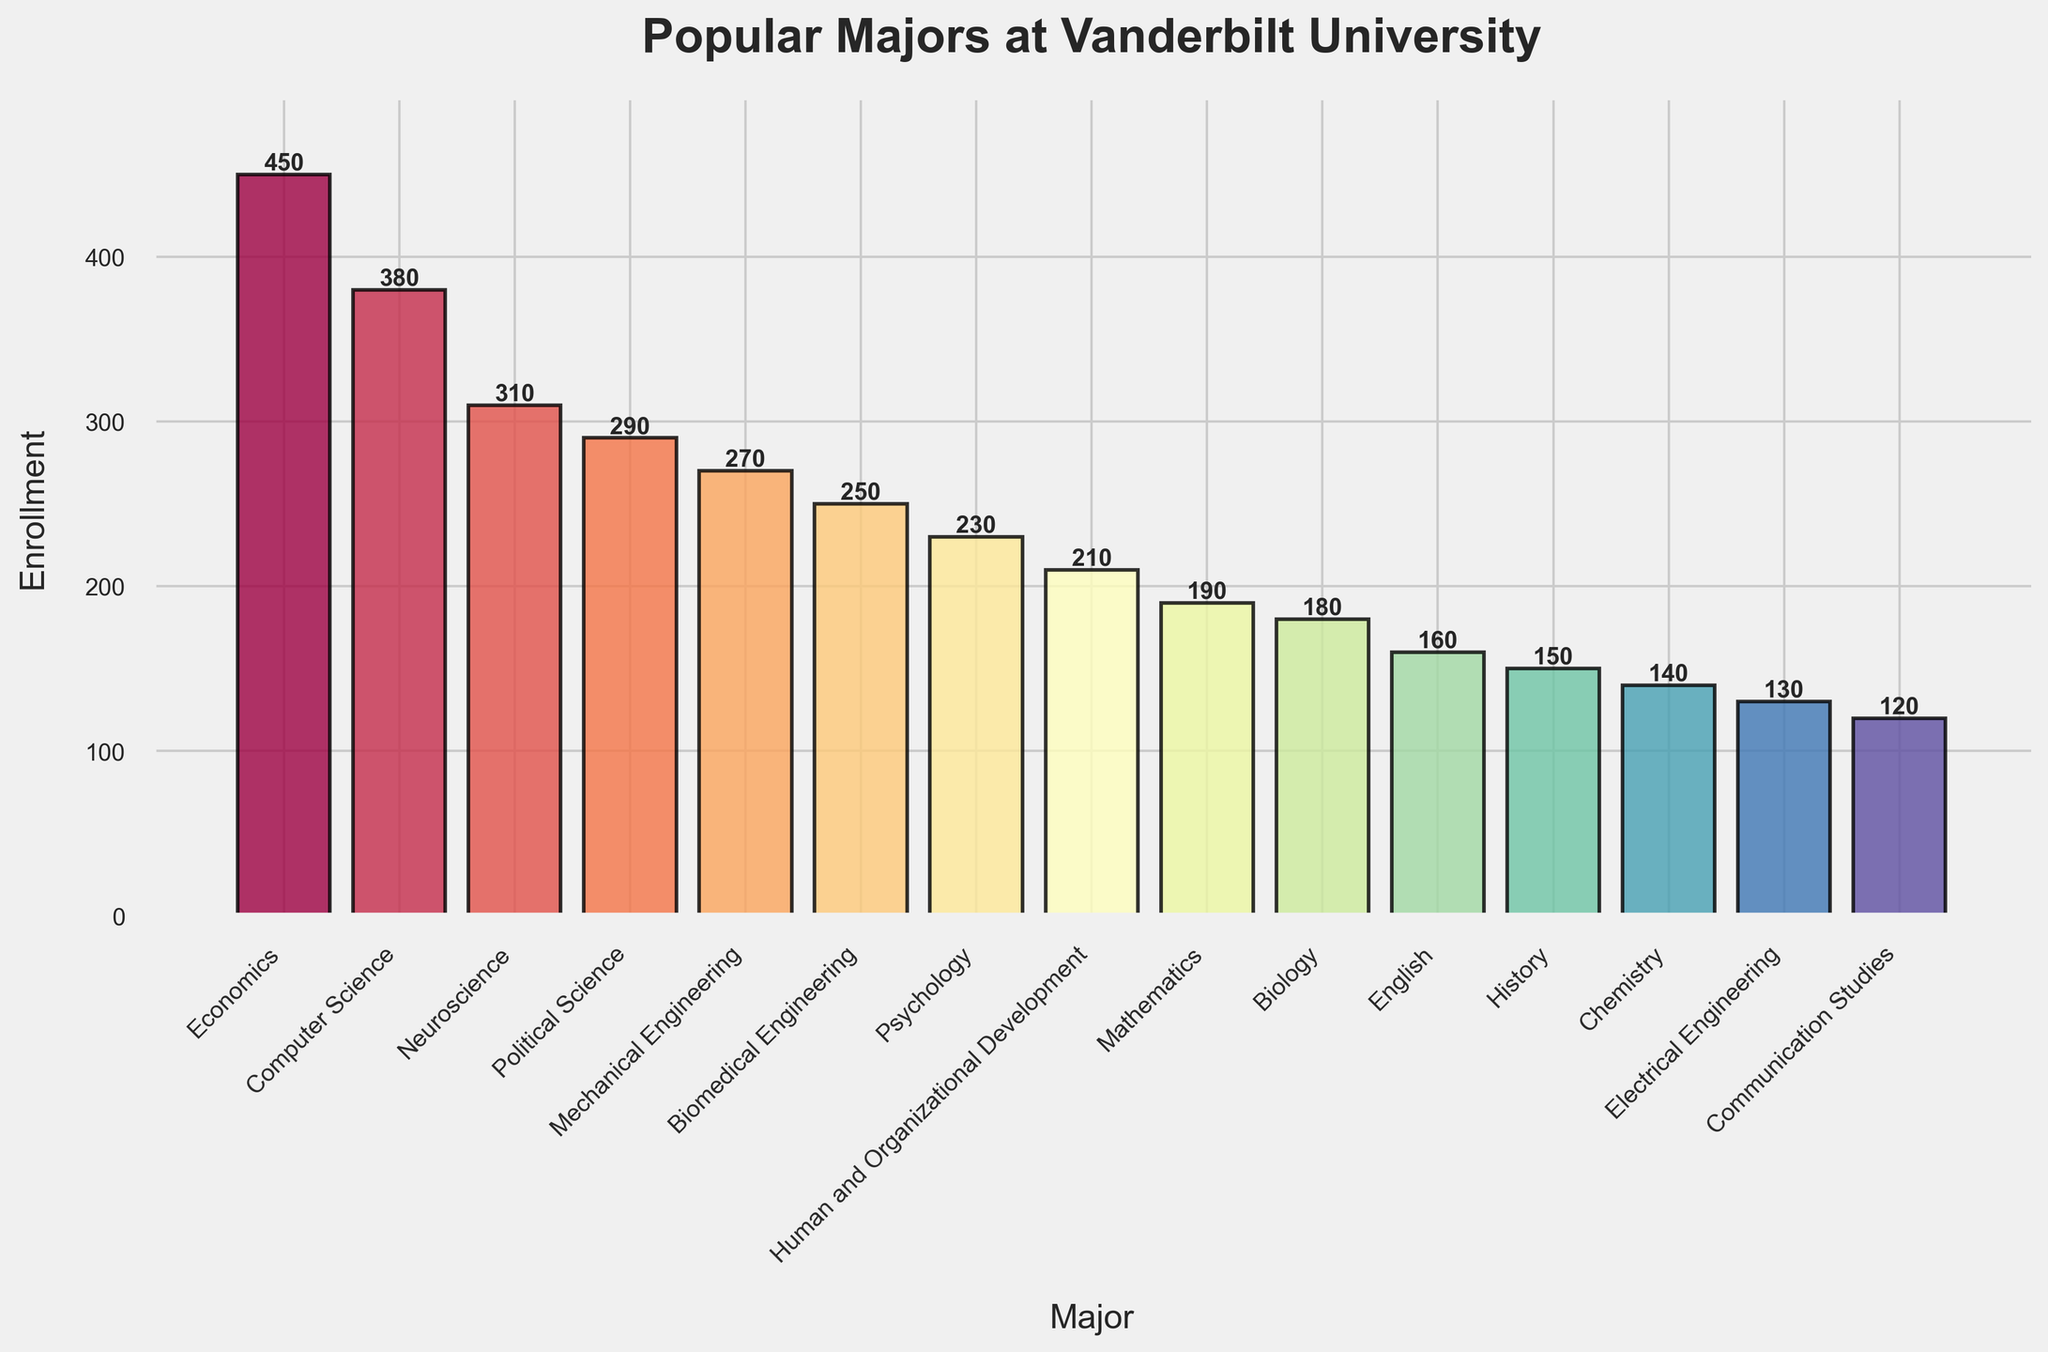Which major has the highest enrollment? By looking at the height of the bars, the tallest bar represents Economics with an enrollment of 450 students.
Answer: Economics Which major has the lowest enrollment? By observing the height of the bars, the shortest bar represents Communication Studies with an enrollment of 120 students.
Answer: Communication Studies What is the difference in enrollment between Economics and Computer Science? The enrollment for Economics is 450, and for Computer Science, it is 380. The difference can be calculated as 450 - 380 = 70.
Answer: 70 How many students are enrolled in the top three most popular majors combined? The top three majors by height of the bars are Economics (450), Computer Science (380), and Neuroscience (310). The combined enrollment is 450 + 380 + 310 = 1140.
Answer: 1140 Is the enrollment in Political Science greater or less than in Mechanical Engineering? By comparing the heights of the bars, Political Science has an enrollment of 290, whereas Mechanical Engineering has 270. Thus, 290 is greater than 270.
Answer: Greater Which majors have enrollments between 200 and 300 students? By inspecting the bars' heights, the majors with enrollments between 200 and 300 are Political Science (290), Mechanical Engineering (270), Biomedical Engineering (250), and Psychology (230).
Answer: Political Science, Mechanical Engineering, Biomedical Engineering, Psychology What is the combined enrollment for all engineering majors listed? The engineering majors listed are Mechanical Engineering (270), Biomedical Engineering (250), and Electrical Engineering (130). The combined enrollment is 270 + 250 + 130 = 650.
Answer: 650 How does the enrollment in Mathematics compare to Biology? By comparing bar heights, Mathematics has an enrollment of 190, whereas Biology has 180. Thus, Mathematics has a slightly higher enrollment than Biology.
Answer: Higher What is the average enrollment of the majors listed in the chart? Sum the enrollments of all the majors and divide by the number of majors: (450 + 380 + 310 + 290 + 270 + 250 + 230 + 210 + 190 + 180 + 160 + 150 + 140 + 130 + 120) / 15 = 3460 / 15 ≈ 231.33.
Answer: Approximately 231 Which major closest to the median enrollment value? Sort the enrollments in ascending order and find the middle value: 120, 130, 140, 150, 160, 180, 190, 210, 230, 250, 270, 290, 310, 380, 450. The median is the 8th value, which is Human and Organizational Development with 210 students.
Answer: Human and Organizational Development 